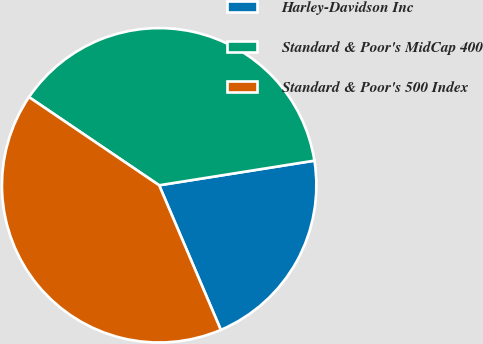<chart> <loc_0><loc_0><loc_500><loc_500><pie_chart><fcel>Harley-Davidson Inc<fcel>Standard & Poor's MidCap 400<fcel>Standard & Poor's 500 Index<nl><fcel>21.09%<fcel>38.02%<fcel>40.89%<nl></chart> 